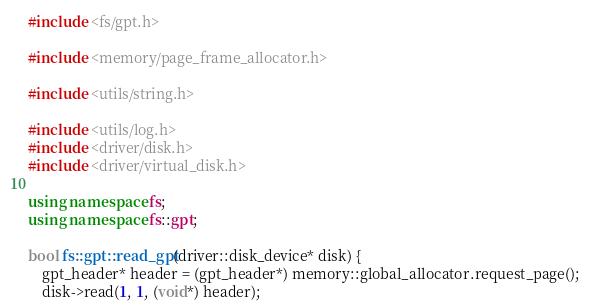<code> <loc_0><loc_0><loc_500><loc_500><_C++_>#include <fs/gpt.h>

#include <memory/page_frame_allocator.h>

#include <utils/string.h>

#include <utils/log.h>
#include <driver/disk.h>
#include <driver/virtual_disk.h>

using namespace fs;
using namespace fs::gpt;

bool fs::gpt::read_gpt(driver::disk_device* disk) {
	gpt_header* header = (gpt_header*) memory::global_allocator.request_page();
	disk->read(1, 1, (void*) header);
</code> 